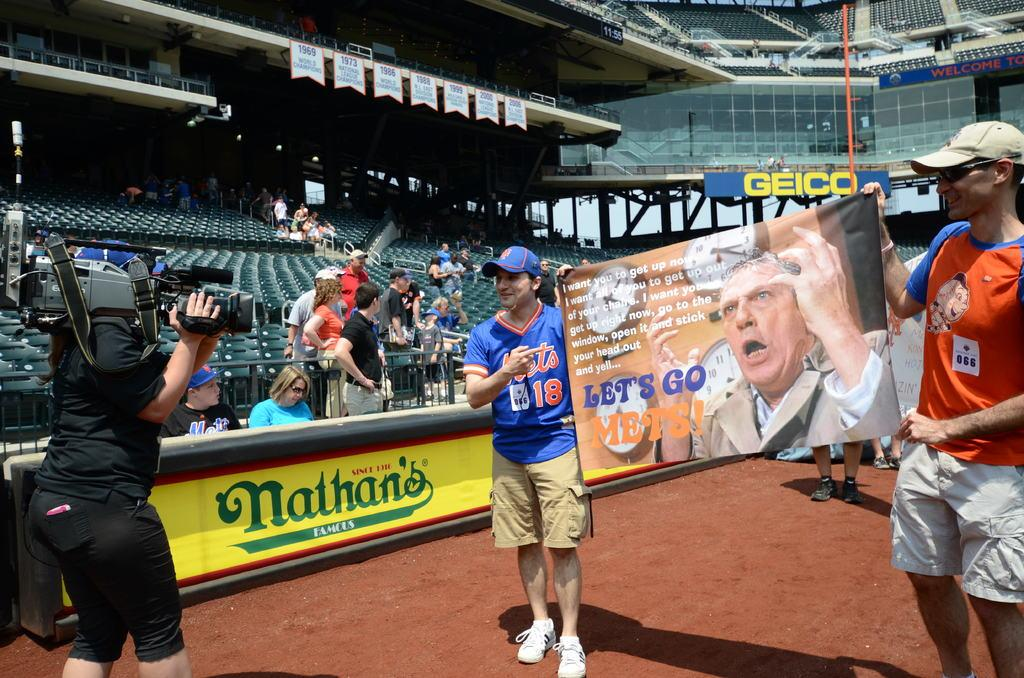<image>
Give a short and clear explanation of the subsequent image. Two fans hold up a poster saying Lets go Mets. 